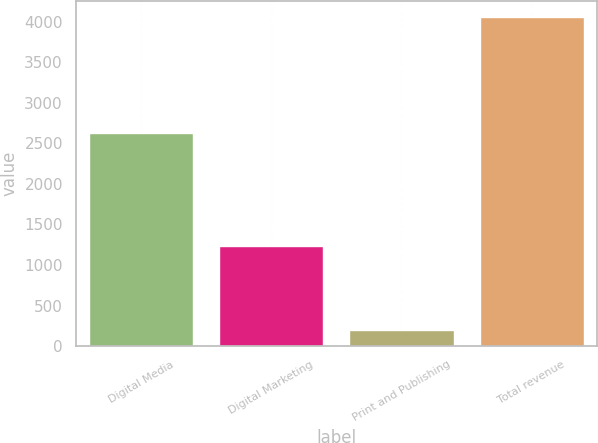<chart> <loc_0><loc_0><loc_500><loc_500><bar_chart><fcel>Digital Media<fcel>Digital Marketing<fcel>Print and Publishing<fcel>Total revenue<nl><fcel>2625.9<fcel>1228.8<fcel>200.5<fcel>4055.2<nl></chart> 